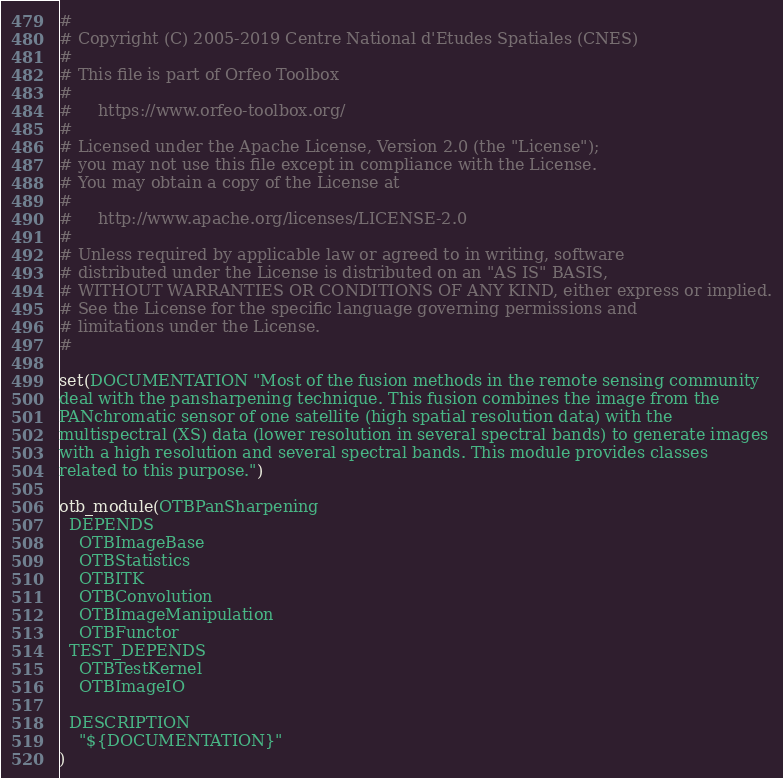<code> <loc_0><loc_0><loc_500><loc_500><_CMake_>#
# Copyright (C) 2005-2019 Centre National d'Etudes Spatiales (CNES)
#
# This file is part of Orfeo Toolbox
#
#     https://www.orfeo-toolbox.org/
#
# Licensed under the Apache License, Version 2.0 (the "License");
# you may not use this file except in compliance with the License.
# You may obtain a copy of the License at
#
#     http://www.apache.org/licenses/LICENSE-2.0
#
# Unless required by applicable law or agreed to in writing, software
# distributed under the License is distributed on an "AS IS" BASIS,
# WITHOUT WARRANTIES OR CONDITIONS OF ANY KIND, either express or implied.
# See the License for the specific language governing permissions and
# limitations under the License.
#

set(DOCUMENTATION "Most of the fusion methods in the remote sensing community
deal with the pansharpening technique. This fusion combines the image from the
PANchromatic sensor of one satellite (high spatial resolution data) with the
multispectral (XS) data (lower resolution in several spectral bands) to generate images
with a high resolution and several spectral bands. This module provides classes
related to this purpose.")

otb_module(OTBPanSharpening
  DEPENDS
    OTBImageBase
    OTBStatistics
    OTBITK
    OTBConvolution
    OTBImageManipulation
    OTBFunctor
  TEST_DEPENDS
    OTBTestKernel
    OTBImageIO

  DESCRIPTION
    "${DOCUMENTATION}"
)
</code> 